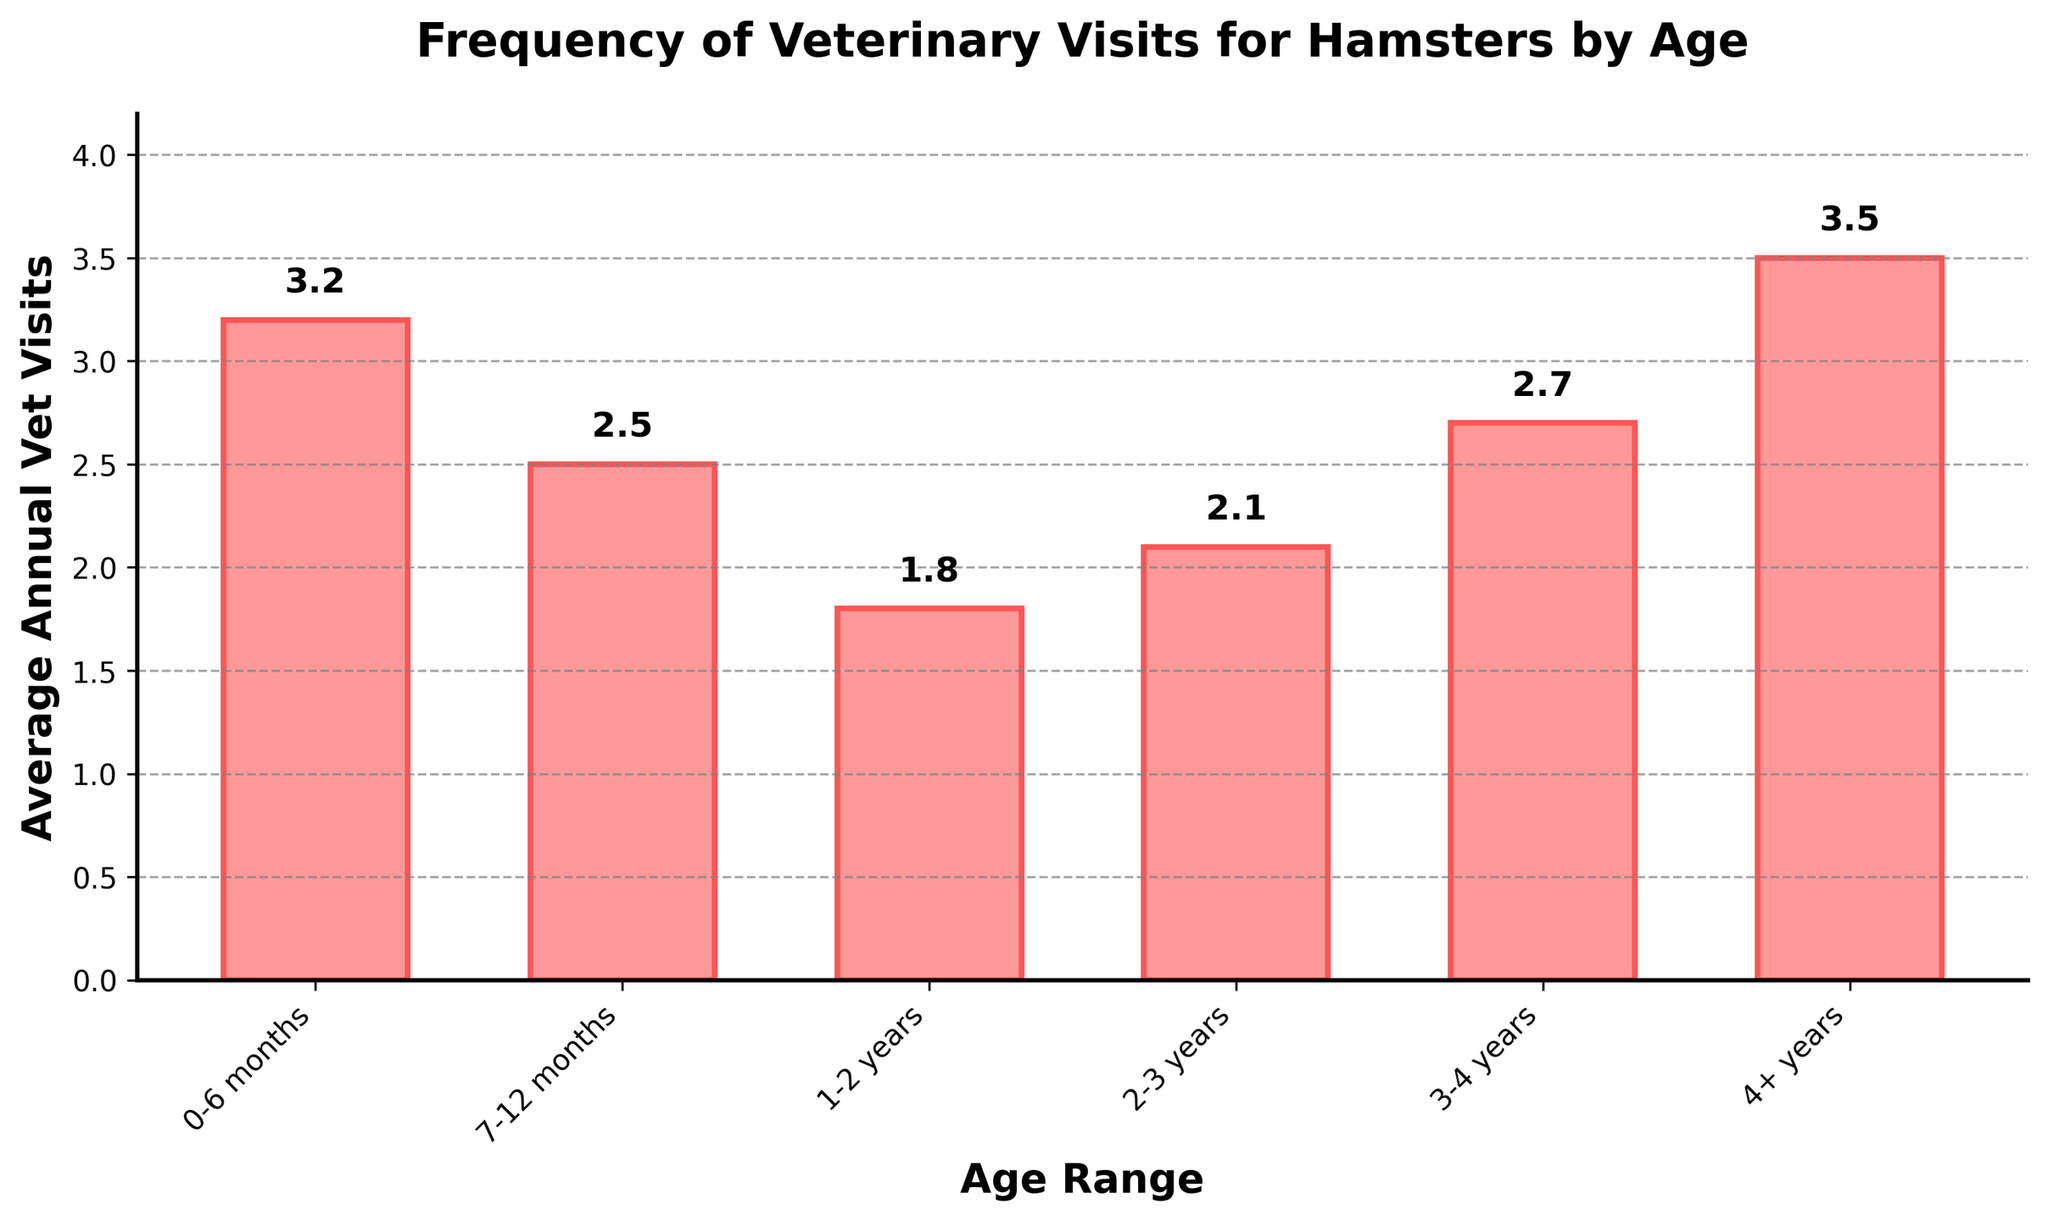How many average annual vet visits does a hamster in the 7-12 months age range have compared to a hamster in the 4+ years age range? First, find the average vet visits for hamsters aged 7-12 months, which is 2.5. Then find the visits for hamsters aged 4+ years, which is 3.5. The difference is 3.5 - 2.5.
Answer: 1.0 Which age range of hamsters has the fewest average annual vet visits? Look at the height of the bars. The lowest bar represents the 1-2 years range, with 1.8 visits.
Answer: 1-2 years What is the total number of average annual vet visits for hamsters aged 0-6 months and hamsters aged 3-4 years? Find the visits for 0-6 months, 3.2, and for 3-4 years, 2.7. Add them together: 3.2 + 2.7.
Answer: 5.9 How does the average annual vet visits trend change from the age range 1-2 years to 2-3 years? Look at the bars for 1-2 years (1.8) and 2-3 years (2.1). The trend shows an increase from 1.8 to 2.1.
Answer: Increase Which age range of hamsters has the highest frequency of vet visits, and what is that frequency? Identify the highest bar, which represents the 4+ years range, with 3.5 visits.
Answer: 4+ years, 3.5 Is there an overall increase or decrease in the frequency of vet visits as hamsters age beyond 2 years? Compare the bars from age 2-3 years (2.1) onward to the 4+ years range. The frequency increases from 2.1 to 2.7 (3-4 years) and then to 3.5 (4+ years).
Answer: Increase By how much do the average annual vet visits for hamsters aged 3-4 years exceed those for hamsters aged 1-2 years? Find the visits for 3-4 years (2.7) and for 1-2 years (1.8). Subtract: 2.7 - 1.8.
Answer: 0.9 What is the average frequency of vet visits for hamsters aged between 4+ years compared to that of all other age groups combined? Combine the total visits for all other age groups: (3.2 + 2.5 + 1.8 + 2.1 + 2.7) = 12.3. There are 5 other age groups, so the average is 12.3/5 = 2.46. Compare this to the 4+ years average of 3.5.
Answer: Higher How much do the average annual vet visits for hamsters older than 3 years (3-4 years and 4+ years combined) differ from those younger than 1 year (0-6 months and 7-12 months combined)? Average for 3-4 years and 4+ years combined is (2.7 + 3.5) / 2 = 3.1. Average for 0-6 months and 7-12 months combined is (3.2 + 2.5) / 2 = 2.85. The difference is 3.1 - 2.85.
Answer: 0.25 